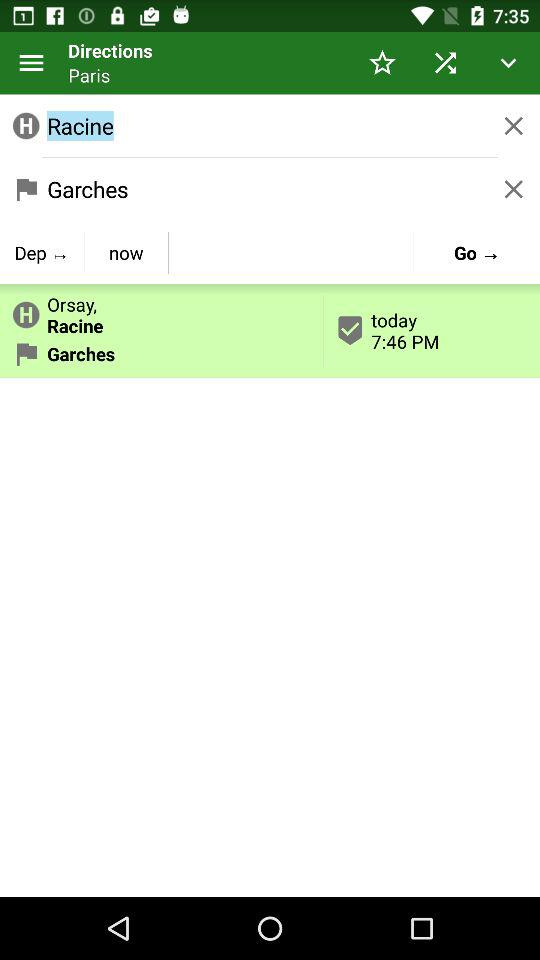What is the name of the city? The name of the city is Paris. 